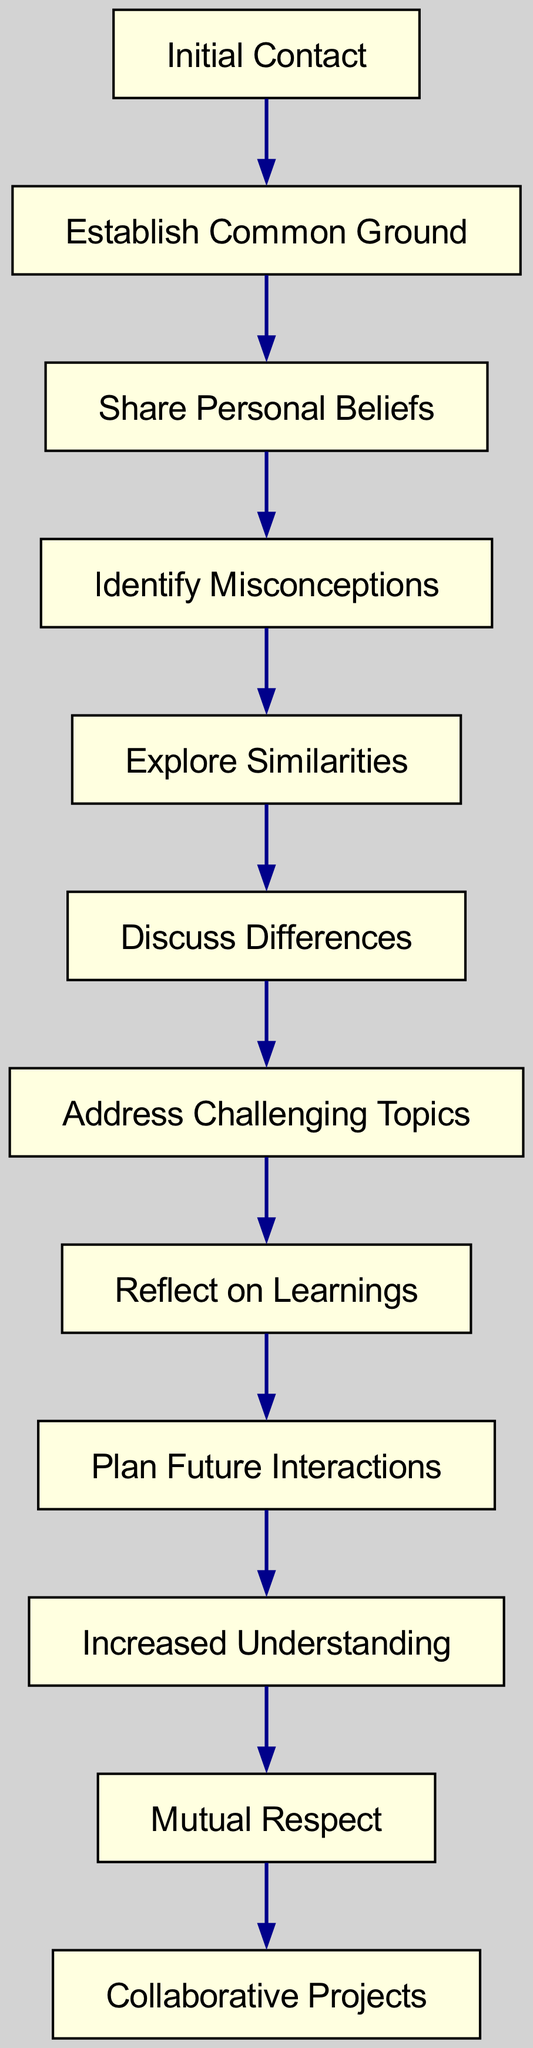What is the first stage of the interfaith dialogue process? The first stage is labeled as "Initial Contact" in the diagram, indicating where the process begins.
Answer: Initial Contact How many nodes are there in the diagram? By counting the different stages represented in the diagram, there are a total of 12 distinct nodes listed.
Answer: 12 What stage comes immediately after "Discuss Differences"? The diagram shows that the stage immediately following "Discuss Differences" is "Address Challenging Topics", which signifies the subsequent step in the flow.
Answer: Address Challenging Topics What potential outcome follows "Increased Understanding"? The diagram specifies that the stage that follows "Increased Understanding" is "Mutual Respect", illustrating a step towards a deeper relationship.
Answer: Mutual Respect What are the last two stages in the dialogue process? The last two stages in the diagram are "Mutual Respect" and "Collaborative Projects", marking the final interactions or outcomes.
Answer: Mutual Respect, Collaborative Projects Which two nodes are directly connected to "Reflect on Learnings"? According to the diagram, "Reflect on Learnings" is directly connected to "Address Challenging Topics" and "Plan Future Interactions", showing its relations to both preceding and subsequent stages.
Answer: Address Challenging Topics, Plan Future Interactions What is the relationship between "Identify Misconceptions" and "Share Personal Beliefs"? The diagram indicates that "Identify Misconceptions" follows directly after "Share Personal Beliefs", meaning it is a successive stage in the dialogue process.
Answer: Identify Misconceptions How many edges are present in the diagram? By examining the connections between the stages, there are 11 edges that show the flow of the dialogue process in the diagram.
Answer: 11 What stage signifies growth in mutual understanding? The stage "Increased Understanding" specifically signifies the growth of mutual understanding among the participants in the dialogue process.
Answer: Increased Understanding 